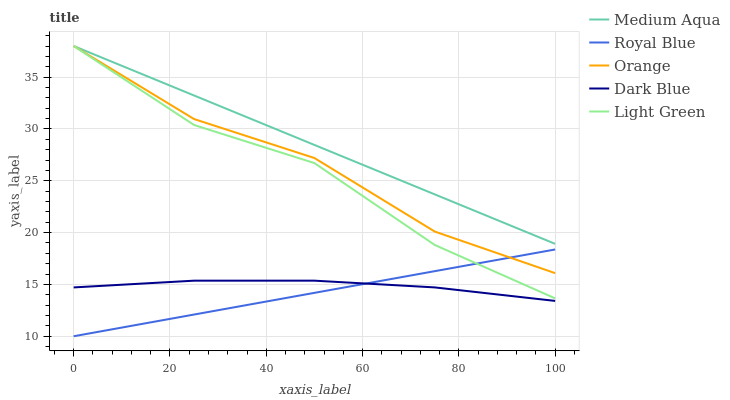Does Royal Blue have the minimum area under the curve?
Answer yes or no. Yes. Does Medium Aqua have the maximum area under the curve?
Answer yes or no. Yes. Does Medium Aqua have the minimum area under the curve?
Answer yes or no. No. Does Royal Blue have the maximum area under the curve?
Answer yes or no. No. Is Royal Blue the smoothest?
Answer yes or no. Yes. Is Light Green the roughest?
Answer yes or no. Yes. Is Medium Aqua the smoothest?
Answer yes or no. No. Is Medium Aqua the roughest?
Answer yes or no. No. Does Medium Aqua have the lowest value?
Answer yes or no. No. Does Light Green have the highest value?
Answer yes or no. Yes. Does Royal Blue have the highest value?
Answer yes or no. No. Is Dark Blue less than Medium Aqua?
Answer yes or no. Yes. Is Medium Aqua greater than Dark Blue?
Answer yes or no. Yes. Does Dark Blue intersect Medium Aqua?
Answer yes or no. No. 